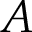Convert formula to latex. <formula><loc_0><loc_0><loc_500><loc_500>A</formula> 